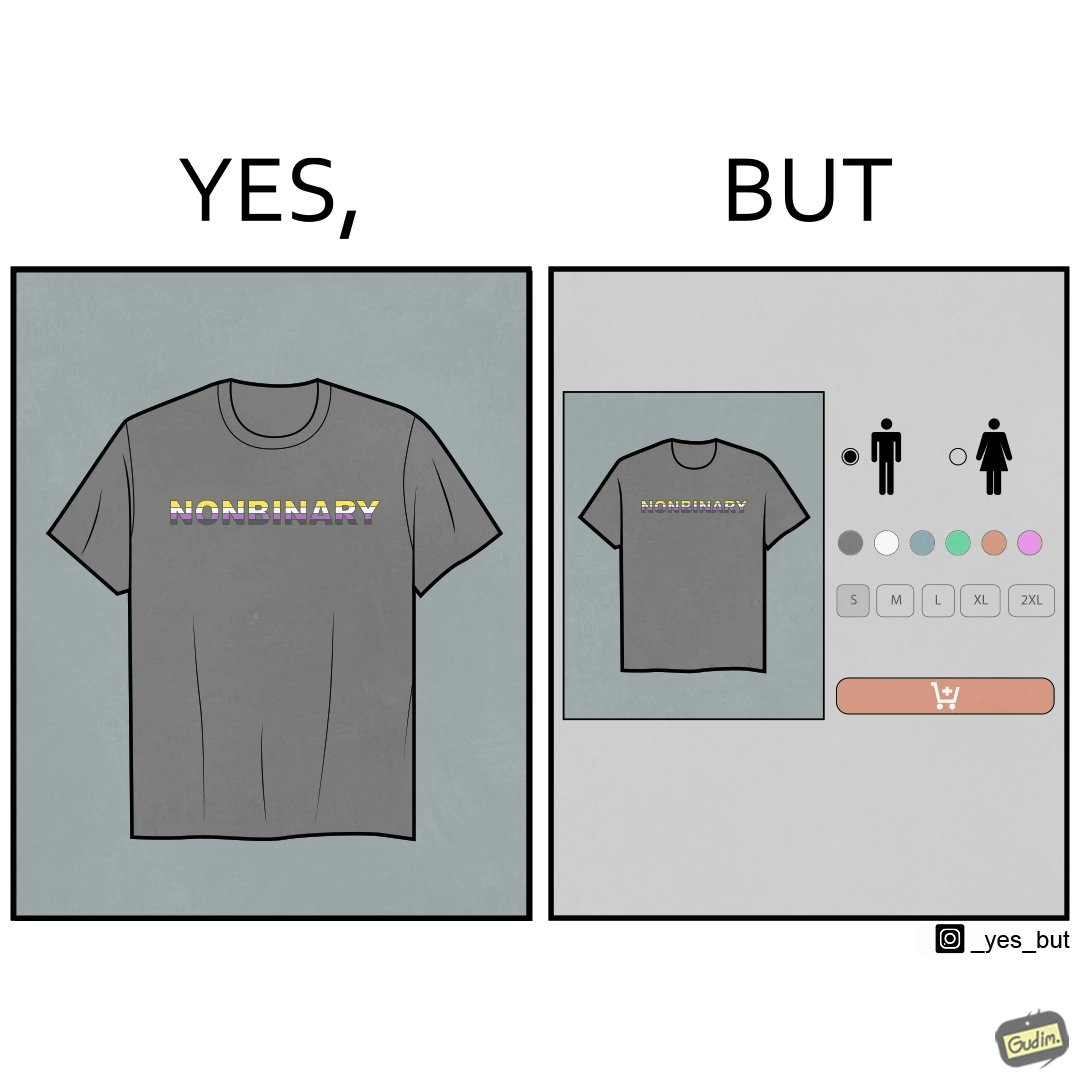Explain the humor or irony in this image. The image is ironic, as the t-shirt that says "NONBINARY" has only 2 options for gender on an online retail forum. 